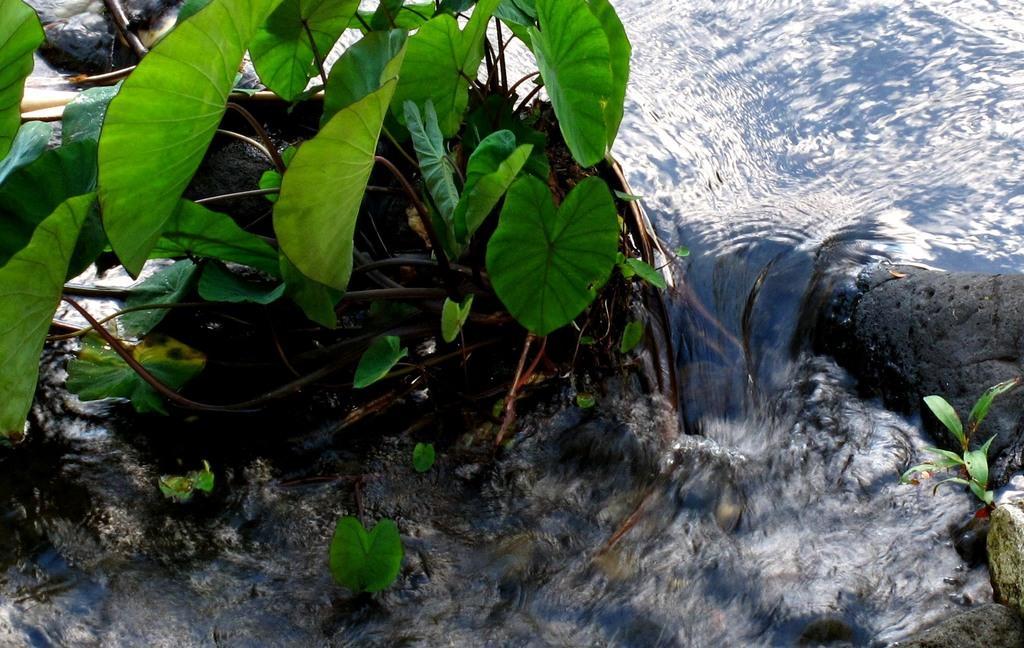In one or two sentences, can you explain what this image depicts? Here in this picture we can see water flowing through a place and we can also see plants present over there. 